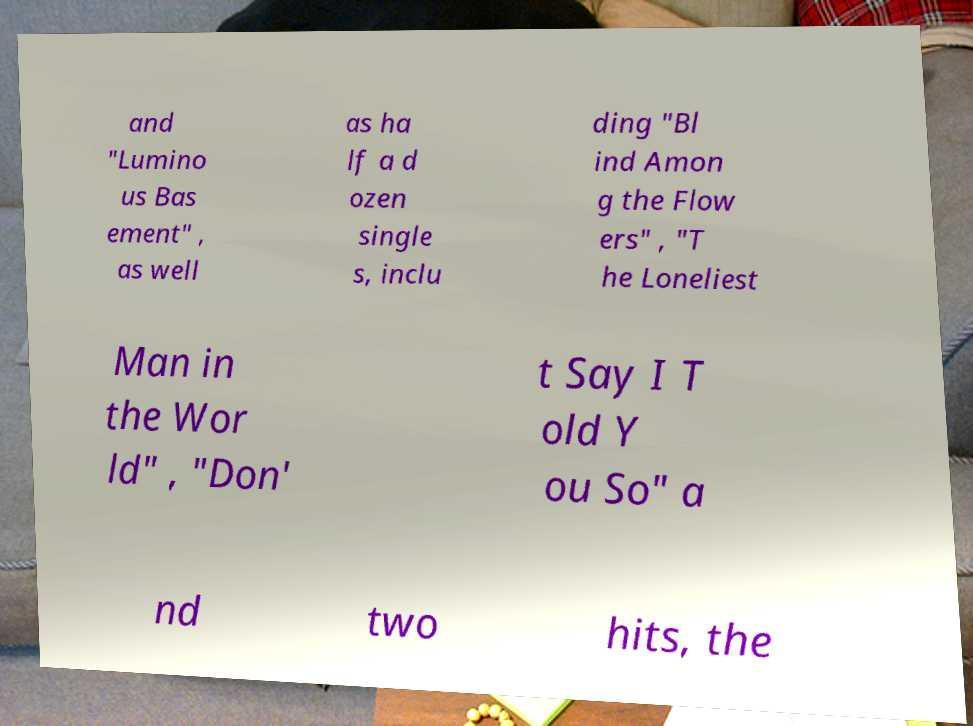Can you read and provide the text displayed in the image?This photo seems to have some interesting text. Can you extract and type it out for me? and "Lumino us Bas ement" , as well as ha lf a d ozen single s, inclu ding "Bl ind Amon g the Flow ers" , "T he Loneliest Man in the Wor ld" , "Don' t Say I T old Y ou So" a nd two hits, the 